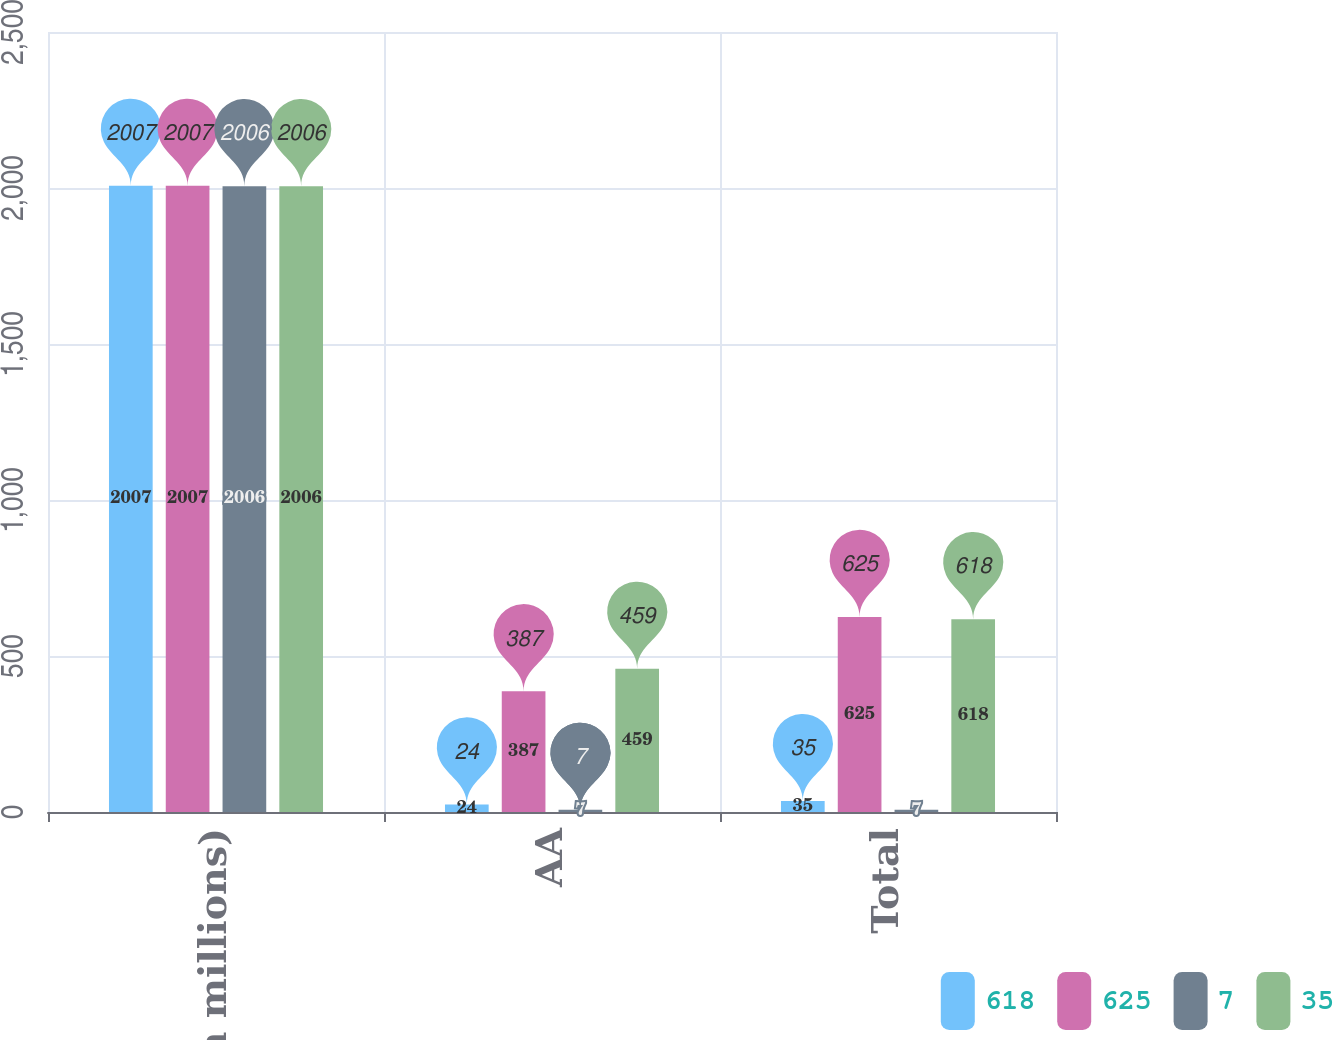Convert chart. <chart><loc_0><loc_0><loc_500><loc_500><stacked_bar_chart><ecel><fcel>(In millions)<fcel>AA<fcel>Total<nl><fcel>618<fcel>2007<fcel>24<fcel>35<nl><fcel>625<fcel>2007<fcel>387<fcel>625<nl><fcel>7<fcel>2006<fcel>7<fcel>7<nl><fcel>35<fcel>2006<fcel>459<fcel>618<nl></chart> 